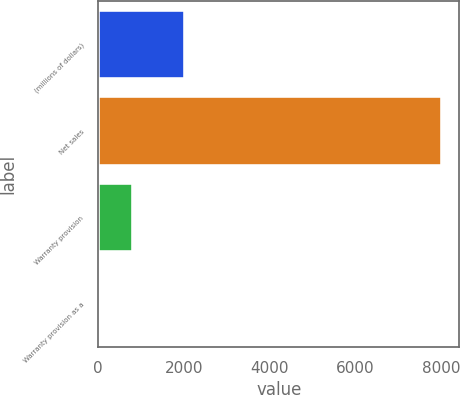<chart> <loc_0><loc_0><loc_500><loc_500><bar_chart><fcel>(millions of dollars)<fcel>Net sales<fcel>Warranty provision<fcel>Warranty provision as a<nl><fcel>2015<fcel>8023.2<fcel>802.68<fcel>0.4<nl></chart> 